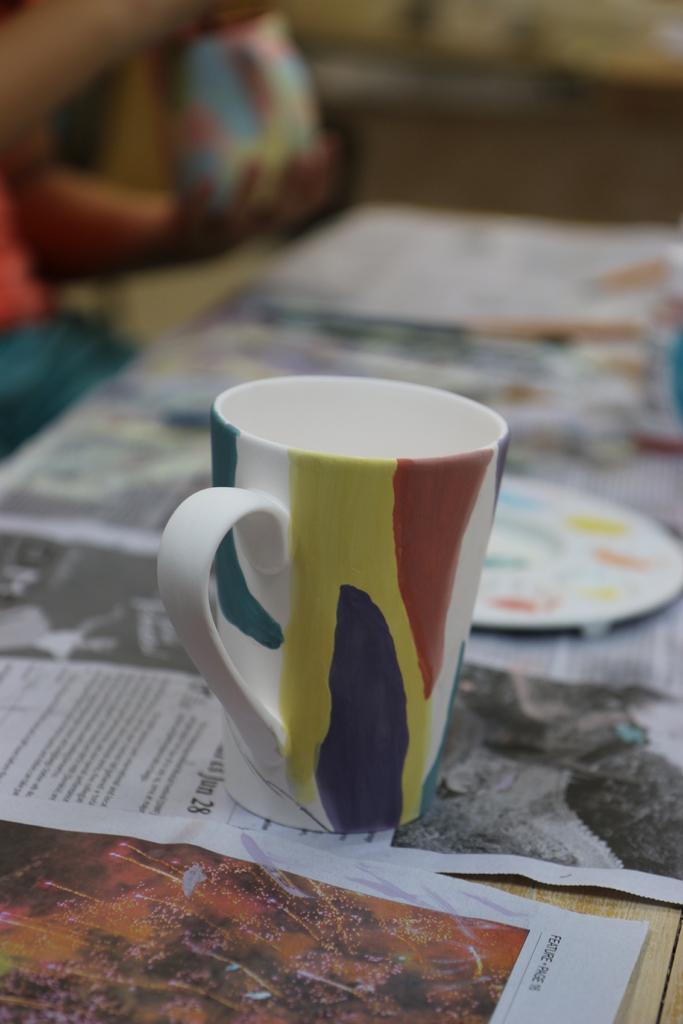What is the main subject of the image? The main subject of the image is a coffee. Where is the coffee placed? The coffee is placed on a sheet of newspaper. What is the sheet of newspaper resting on? The sheet of newspaper is on a table. What type of face can be seen on the coffee in the image? There is no face present on the coffee in the image. Is there a gate visible in the image? There is no gate present in the image. 